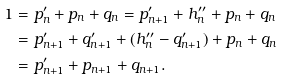<formula> <loc_0><loc_0><loc_500><loc_500>1 & = p ^ { \prime } _ { n } + p _ { n } + q _ { n } = p ^ { \prime } _ { n + 1 } + h ^ { \prime \prime } _ { n } + p _ { n } + q _ { n } \\ & = p ^ { \prime } _ { n + 1 } + q ^ { \prime } _ { n + 1 } + ( h _ { n } ^ { \prime \prime } - q ^ { \prime } _ { n + 1 } ) + p _ { n } + q _ { n } \\ & = p ^ { \prime } _ { n + 1 } + p _ { n + 1 } + q _ { n + 1 } .</formula> 